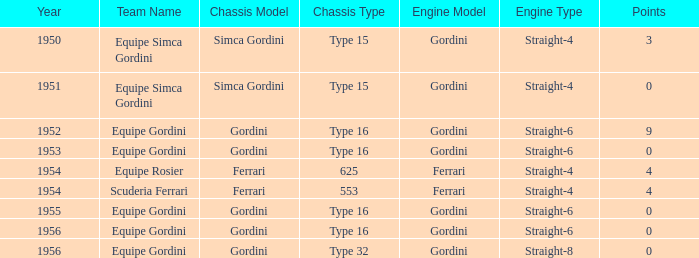What chassis has smaller than 9 points by Equipe Rosier? Ferrari 625. 